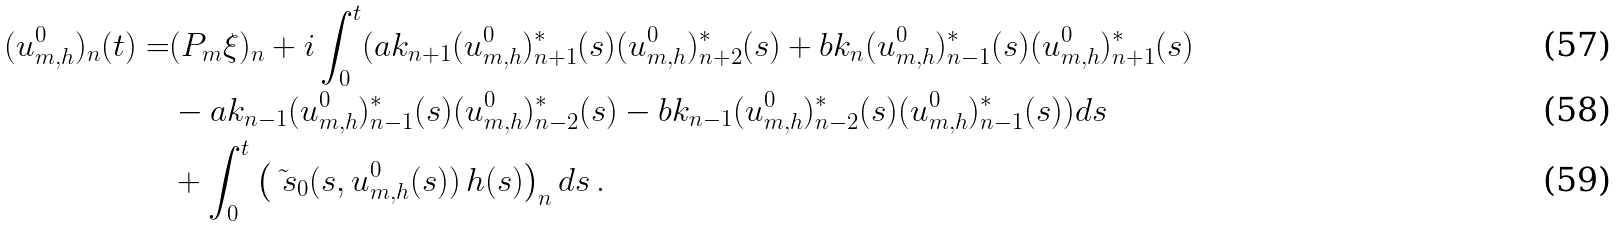Convert formula to latex. <formula><loc_0><loc_0><loc_500><loc_500>( u ^ { 0 } _ { m , h } ) _ { n } ( t ) = & ( P _ { m } \xi ) _ { n } + i \int _ { 0 } ^ { t } ( a k _ { n + 1 } ( u ^ { 0 } _ { m , h } ) _ { n + 1 } ^ { * } ( s ) ( u ^ { 0 } _ { m , h } ) _ { n + 2 } ^ { * } ( s ) + b k _ { n } ( u ^ { 0 } _ { m , h } ) _ { n - 1 } ^ { * } ( s ) ( u ^ { 0 } _ { m , h } ) _ { n + 1 } ^ { * } ( s ) \\ & - a k _ { n - 1 } ( u ^ { 0 } _ { m , h } ) _ { n - 1 } ^ { * } ( s ) ( u ^ { 0 } _ { m , h } ) _ { n - 2 } ^ { * } ( s ) - b k _ { n - 1 } ( u ^ { 0 } _ { m , h } ) _ { n - 2 } ^ { * } ( s ) ( u ^ { 0 } _ { m , h } ) _ { n - 1 } ^ { * } ( s ) ) d s \\ & + \int _ { 0 } ^ { t } \left ( \tilde { \ s } _ { 0 } ( s , u ^ { 0 } _ { m , h } ( s ) ) \, h ( s ) \right ) _ { n } d s \, .</formula> 